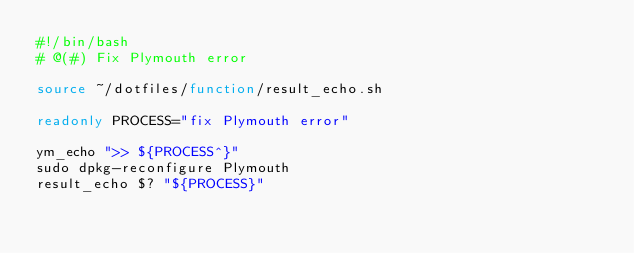<code> <loc_0><loc_0><loc_500><loc_500><_Bash_>#!/bin/bash
# @(#) Fix Plymouth error

source ~/dotfiles/function/result_echo.sh

readonly PROCESS="fix Plymouth error"

ym_echo ">> ${PROCESS^}"
sudo dpkg-reconfigure Plymouth
result_echo $? "${PROCESS}"
</code> 